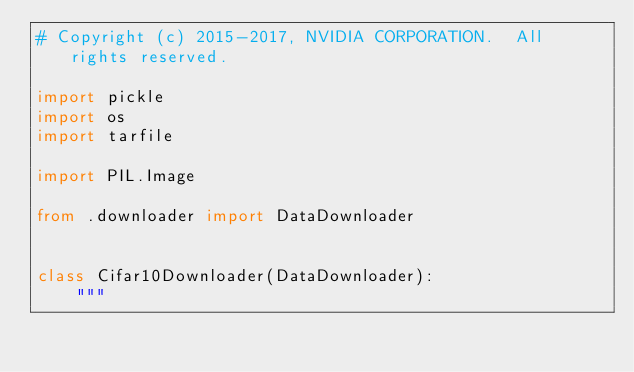Convert code to text. <code><loc_0><loc_0><loc_500><loc_500><_Python_># Copyright (c) 2015-2017, NVIDIA CORPORATION.  All rights reserved.

import pickle
import os
import tarfile

import PIL.Image

from .downloader import DataDownloader


class Cifar10Downloader(DataDownloader):
    """</code> 